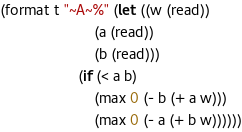Convert code to text. <code><loc_0><loc_0><loc_500><loc_500><_Lisp_>(format t "~A~%" (let ((w (read))
                       (a (read))
                       (b (read)))
                   (if (< a b)
                       (max 0 (- b (+ a w)))
                       (max 0 (- a (+ b w))))))</code> 